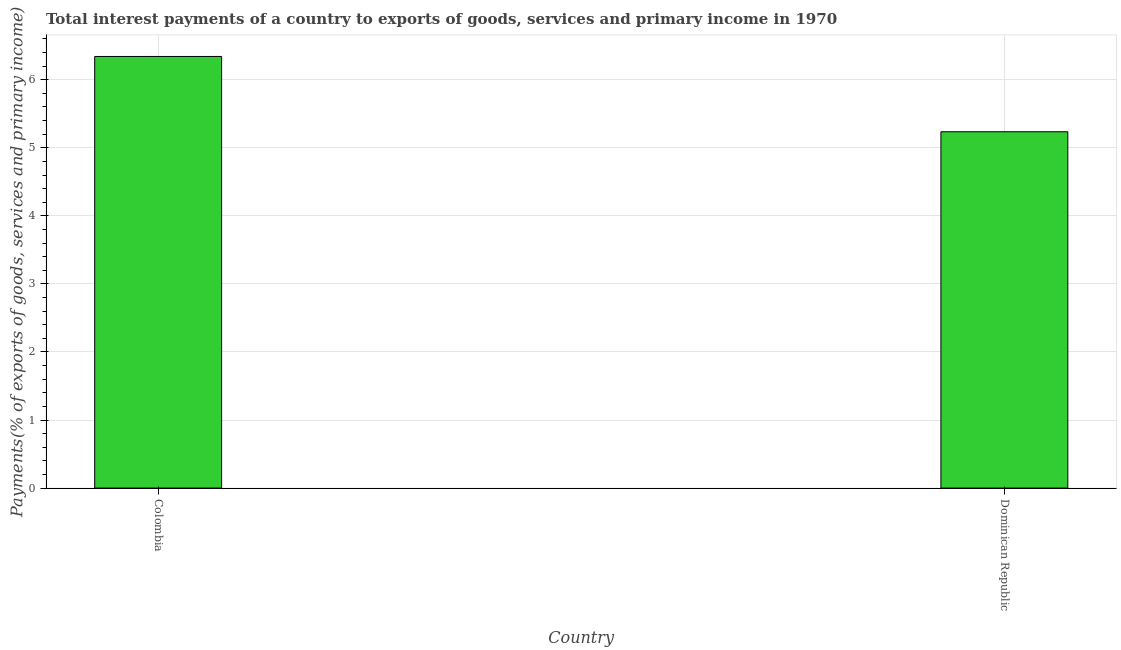Does the graph contain any zero values?
Your answer should be very brief. No. Does the graph contain grids?
Your answer should be compact. Yes. What is the title of the graph?
Give a very brief answer. Total interest payments of a country to exports of goods, services and primary income in 1970. What is the label or title of the Y-axis?
Provide a short and direct response. Payments(% of exports of goods, services and primary income). What is the total interest payments on external debt in Colombia?
Your answer should be very brief. 6.34. Across all countries, what is the maximum total interest payments on external debt?
Your answer should be very brief. 6.34. Across all countries, what is the minimum total interest payments on external debt?
Give a very brief answer. 5.24. In which country was the total interest payments on external debt minimum?
Provide a succinct answer. Dominican Republic. What is the sum of the total interest payments on external debt?
Make the answer very short. 11.58. What is the difference between the total interest payments on external debt in Colombia and Dominican Republic?
Your answer should be compact. 1.11. What is the average total interest payments on external debt per country?
Your answer should be compact. 5.79. What is the median total interest payments on external debt?
Your answer should be compact. 5.79. What is the ratio of the total interest payments on external debt in Colombia to that in Dominican Republic?
Provide a short and direct response. 1.21. In how many countries, is the total interest payments on external debt greater than the average total interest payments on external debt taken over all countries?
Keep it short and to the point. 1. How many bars are there?
Your answer should be compact. 2. Are all the bars in the graph horizontal?
Your answer should be very brief. No. How many countries are there in the graph?
Your answer should be very brief. 2. Are the values on the major ticks of Y-axis written in scientific E-notation?
Your answer should be very brief. No. What is the Payments(% of exports of goods, services and primary income) in Colombia?
Make the answer very short. 6.34. What is the Payments(% of exports of goods, services and primary income) in Dominican Republic?
Make the answer very short. 5.24. What is the difference between the Payments(% of exports of goods, services and primary income) in Colombia and Dominican Republic?
Your response must be concise. 1.11. What is the ratio of the Payments(% of exports of goods, services and primary income) in Colombia to that in Dominican Republic?
Your response must be concise. 1.21. 